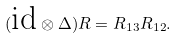Convert formula to latex. <formula><loc_0><loc_0><loc_500><loc_500>( \text {id} \otimes \Delta ) R = R _ { 1 3 } R _ { 1 2 } .</formula> 